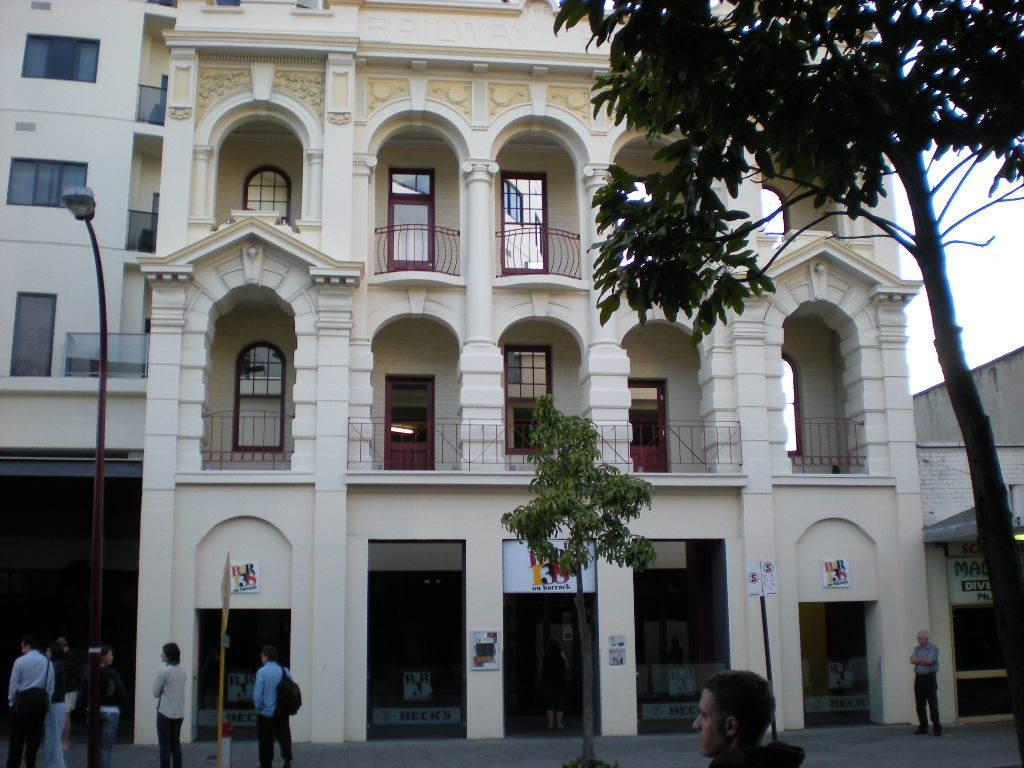What structure is the main subject of the image? There is a building in the image. What is happening in front of the building? There are people standing in front of the building. What type of vegetation is present in the image? There are trees in the image. What type of lighting is present in the image? There is a street light in the image. What can be seen in the background of the image? The sky is visible in the background of the image. What book is the coach reading with their partner in the image? There is no coach, book, or partner present in the image. 